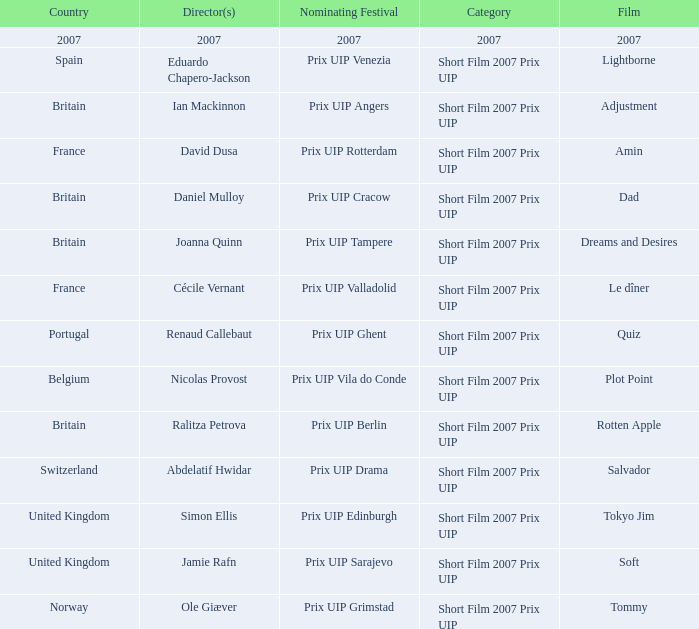What country was the prix uip ghent nominating festival? Portugal. Parse the table in full. {'header': ['Country', 'Director(s)', 'Nominating Festival', 'Category', 'Film'], 'rows': [['2007', '2007', '2007', '2007', '2007'], ['Spain', 'Eduardo Chapero-Jackson', 'Prix UIP Venezia', 'Short Film 2007 Prix UIP', 'Lightborne'], ['Britain', 'Ian Mackinnon', 'Prix UIP Angers', 'Short Film 2007 Prix UIP', 'Adjustment'], ['France', 'David Dusa', 'Prix UIP Rotterdam', 'Short Film 2007 Prix UIP', 'Amin'], ['Britain', 'Daniel Mulloy', 'Prix UIP Cracow', 'Short Film 2007 Prix UIP', 'Dad'], ['Britain', 'Joanna Quinn', 'Prix UIP Tampere', 'Short Film 2007 Prix UIP', 'Dreams and Desires'], ['France', 'Cécile Vernant', 'Prix UIP Valladolid', 'Short Film 2007 Prix UIP', 'Le dîner'], ['Portugal', 'Renaud Callebaut', 'Prix UIP Ghent', 'Short Film 2007 Prix UIP', 'Quiz'], ['Belgium', 'Nicolas Provost', 'Prix UIP Vila do Conde', 'Short Film 2007 Prix UIP', 'Plot Point'], ['Britain', 'Ralitza Petrova', 'Prix UIP Berlin', 'Short Film 2007 Prix UIP', 'Rotten Apple'], ['Switzerland', 'Abdelatif Hwidar', 'Prix UIP Drama', 'Short Film 2007 Prix UIP', 'Salvador'], ['United Kingdom', 'Simon Ellis', 'Prix UIP Edinburgh', 'Short Film 2007 Prix UIP', 'Tokyo Jim'], ['United Kingdom', 'Jamie Rafn', 'Prix UIP Sarajevo', 'Short Film 2007 Prix UIP', 'Soft'], ['Norway', 'Ole Giæver', 'Prix UIP Grimstad', 'Short Film 2007 Prix UIP', 'Tommy']]} 